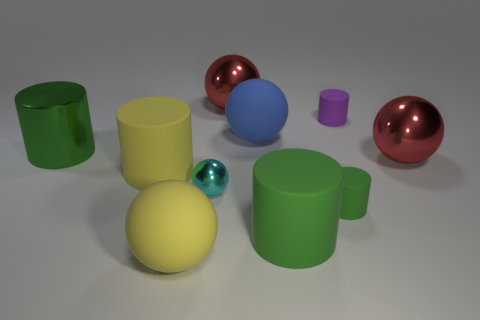How many green cylinders must be subtracted to get 1 green cylinders? 2 Subtract all yellow cubes. How many green cylinders are left? 3 Subtract 2 balls. How many balls are left? 3 Add 7 tiny things. How many tiny things are left? 10 Add 2 tiny matte cylinders. How many tiny matte cylinders exist? 4 Subtract 1 purple cylinders. How many objects are left? 9 Subtract all cyan balls. Subtract all cyan objects. How many objects are left? 8 